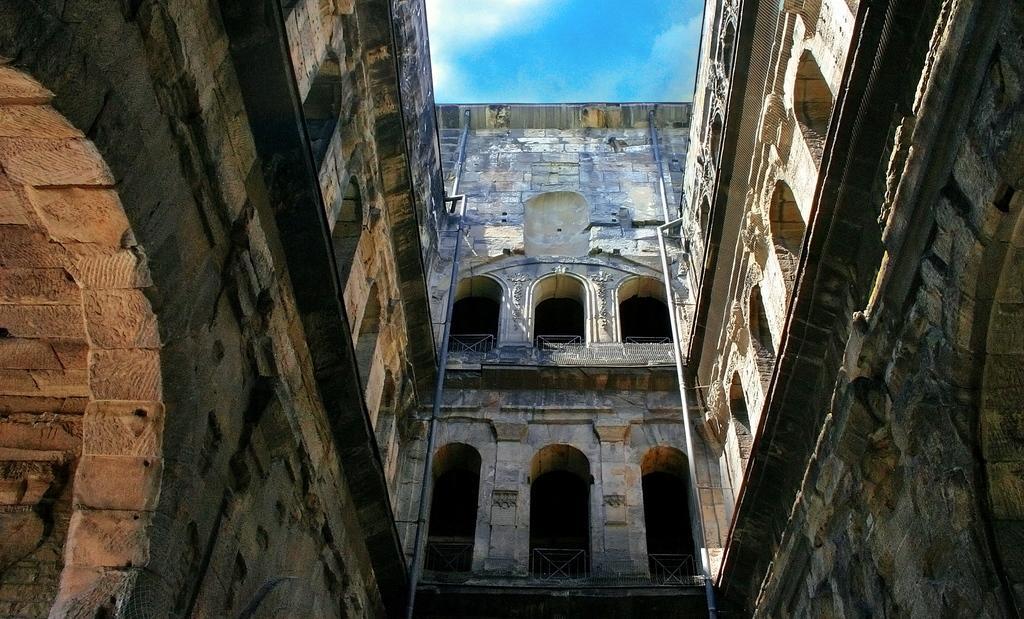Can you describe this image briefly? In this image we can see a building. These are pipes. Sky is in blue color. These are clouds. 